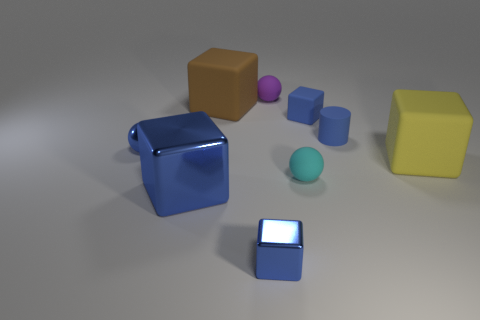What is the size of the metallic sphere that is the same color as the small rubber cube?
Offer a terse response. Small. There is a cylinder that is the same color as the large metallic thing; what is it made of?
Provide a short and direct response. Rubber. What number of things are large matte things behind the blue metallic ball or large blue rubber objects?
Offer a very short reply. 1. There is a matte object in front of the large yellow matte block on the right side of the tiny blue rubber block; what shape is it?
Make the answer very short. Sphere. Is there another thing of the same size as the brown thing?
Provide a short and direct response. Yes. Is the number of tiny purple cubes greater than the number of brown rubber blocks?
Your response must be concise. No. Is the size of the blue metal thing that is to the right of the large brown object the same as the rubber cube to the right of the small blue rubber cube?
Your response must be concise. No. What number of tiny objects are on the right side of the tiny blue metallic ball and in front of the rubber cylinder?
Ensure brevity in your answer.  2. There is another small rubber thing that is the same shape as the cyan matte thing; what color is it?
Provide a succinct answer. Purple. Is the number of tiny purple metal objects less than the number of blue cylinders?
Offer a terse response. Yes. 